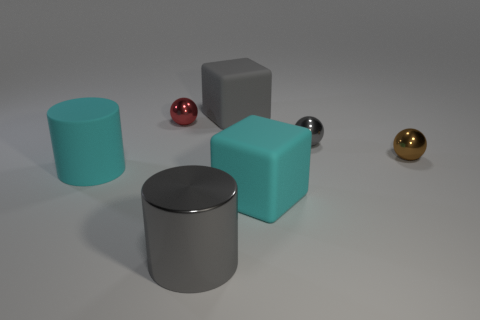There is a small red metallic sphere; how many cylinders are on the left side of it?
Provide a succinct answer. 1. What is the shape of the small metallic object that is right of the gray metal cylinder and left of the tiny brown metal thing?
Keep it short and to the point. Sphere. What is the material of the tiny object that is the same color as the shiny cylinder?
Your answer should be very brief. Metal. What number of cylinders are either gray rubber objects or small shiny things?
Give a very brief answer. 0. What is the size of the rubber thing that is the same color as the big shiny thing?
Offer a very short reply. Large. Are there fewer gray matte blocks that are on the left side of the big gray metal object than cyan things?
Offer a terse response. Yes. There is a rubber object that is in front of the gray metallic sphere and on the left side of the large cyan block; what color is it?
Offer a very short reply. Cyan. How many other objects are the same shape as the small gray metallic thing?
Provide a short and direct response. 2. Are there fewer gray matte objects that are in front of the large cyan rubber cube than metal cylinders to the right of the tiny red ball?
Provide a short and direct response. Yes. Is the material of the tiny red sphere the same as the cyan object that is right of the large gray cylinder?
Your answer should be compact. No. 